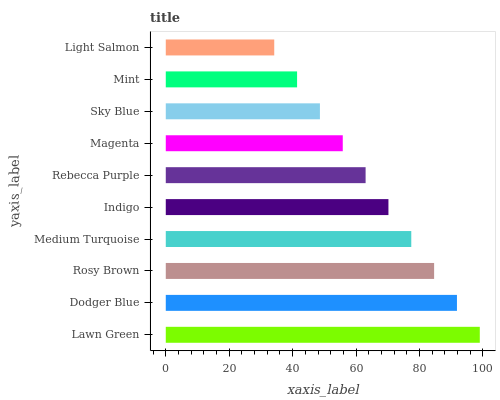Is Light Salmon the minimum?
Answer yes or no. Yes. Is Lawn Green the maximum?
Answer yes or no. Yes. Is Dodger Blue the minimum?
Answer yes or no. No. Is Dodger Blue the maximum?
Answer yes or no. No. Is Lawn Green greater than Dodger Blue?
Answer yes or no. Yes. Is Dodger Blue less than Lawn Green?
Answer yes or no. Yes. Is Dodger Blue greater than Lawn Green?
Answer yes or no. No. Is Lawn Green less than Dodger Blue?
Answer yes or no. No. Is Indigo the high median?
Answer yes or no. Yes. Is Rebecca Purple the low median?
Answer yes or no. Yes. Is Rebecca Purple the high median?
Answer yes or no. No. Is Sky Blue the low median?
Answer yes or no. No. 